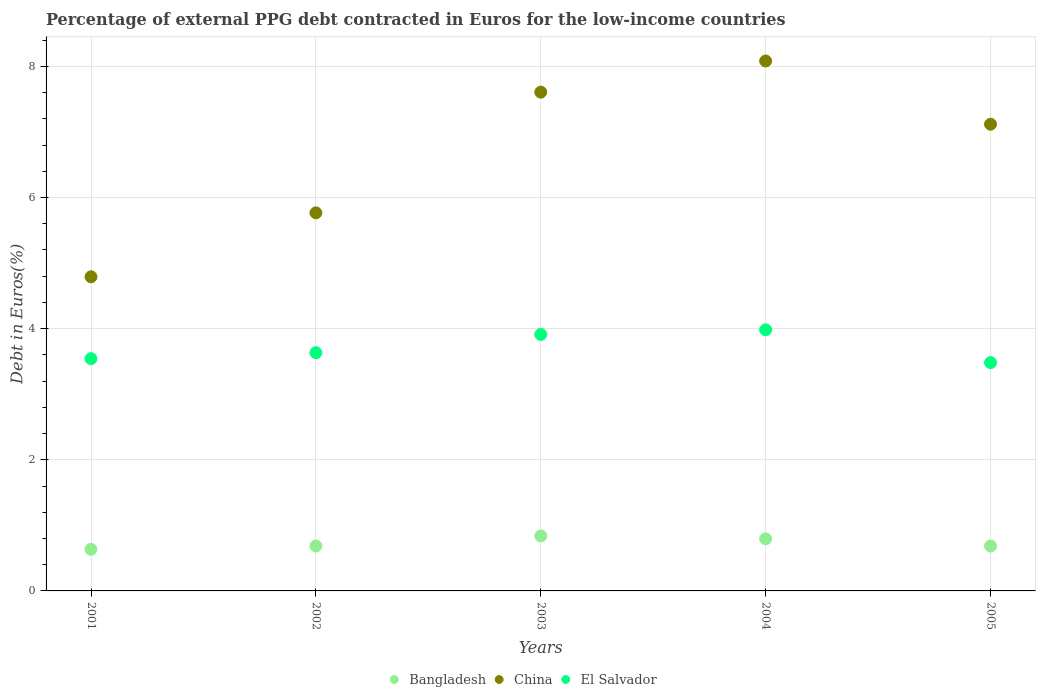How many different coloured dotlines are there?
Your response must be concise. 3. What is the percentage of external PPG debt contracted in Euros in Bangladesh in 2003?
Ensure brevity in your answer.  0.84. Across all years, what is the maximum percentage of external PPG debt contracted in Euros in El Salvador?
Your answer should be very brief. 3.98. Across all years, what is the minimum percentage of external PPG debt contracted in Euros in Bangladesh?
Your answer should be very brief. 0.63. In which year was the percentage of external PPG debt contracted in Euros in El Salvador maximum?
Your answer should be compact. 2004. What is the total percentage of external PPG debt contracted in Euros in El Salvador in the graph?
Your response must be concise. 18.55. What is the difference between the percentage of external PPG debt contracted in Euros in El Salvador in 2003 and that in 2005?
Give a very brief answer. 0.43. What is the difference between the percentage of external PPG debt contracted in Euros in China in 2002 and the percentage of external PPG debt contracted in Euros in El Salvador in 2005?
Your response must be concise. 2.28. What is the average percentage of external PPG debt contracted in Euros in China per year?
Provide a succinct answer. 6.67. In the year 2003, what is the difference between the percentage of external PPG debt contracted in Euros in Bangladesh and percentage of external PPG debt contracted in Euros in El Salvador?
Your response must be concise. -3.07. What is the ratio of the percentage of external PPG debt contracted in Euros in El Salvador in 2001 to that in 2003?
Provide a succinct answer. 0.91. Is the difference between the percentage of external PPG debt contracted in Euros in Bangladesh in 2001 and 2002 greater than the difference between the percentage of external PPG debt contracted in Euros in El Salvador in 2001 and 2002?
Provide a short and direct response. Yes. What is the difference between the highest and the second highest percentage of external PPG debt contracted in Euros in Bangladesh?
Ensure brevity in your answer.  0.04. What is the difference between the highest and the lowest percentage of external PPG debt contracted in Euros in China?
Offer a very short reply. 3.29. In how many years, is the percentage of external PPG debt contracted in Euros in Bangladesh greater than the average percentage of external PPG debt contracted in Euros in Bangladesh taken over all years?
Your answer should be very brief. 2. Is it the case that in every year, the sum of the percentage of external PPG debt contracted in Euros in China and percentage of external PPG debt contracted in Euros in Bangladesh  is greater than the percentage of external PPG debt contracted in Euros in El Salvador?
Make the answer very short. Yes. Is the percentage of external PPG debt contracted in Euros in Bangladesh strictly greater than the percentage of external PPG debt contracted in Euros in China over the years?
Provide a short and direct response. No. How many dotlines are there?
Your response must be concise. 3. How many years are there in the graph?
Give a very brief answer. 5. Are the values on the major ticks of Y-axis written in scientific E-notation?
Offer a very short reply. No. How many legend labels are there?
Ensure brevity in your answer.  3. How are the legend labels stacked?
Your answer should be very brief. Horizontal. What is the title of the graph?
Offer a very short reply. Percentage of external PPG debt contracted in Euros for the low-income countries. What is the label or title of the Y-axis?
Offer a very short reply. Debt in Euros(%). What is the Debt in Euros(%) in Bangladesh in 2001?
Ensure brevity in your answer.  0.63. What is the Debt in Euros(%) in China in 2001?
Your answer should be compact. 4.79. What is the Debt in Euros(%) in El Salvador in 2001?
Your answer should be compact. 3.54. What is the Debt in Euros(%) in Bangladesh in 2002?
Provide a short and direct response. 0.69. What is the Debt in Euros(%) in China in 2002?
Your answer should be compact. 5.77. What is the Debt in Euros(%) in El Salvador in 2002?
Keep it short and to the point. 3.63. What is the Debt in Euros(%) of Bangladesh in 2003?
Give a very brief answer. 0.84. What is the Debt in Euros(%) in China in 2003?
Keep it short and to the point. 7.61. What is the Debt in Euros(%) in El Salvador in 2003?
Keep it short and to the point. 3.91. What is the Debt in Euros(%) in Bangladesh in 2004?
Ensure brevity in your answer.  0.79. What is the Debt in Euros(%) of China in 2004?
Keep it short and to the point. 8.08. What is the Debt in Euros(%) of El Salvador in 2004?
Provide a short and direct response. 3.98. What is the Debt in Euros(%) of Bangladesh in 2005?
Ensure brevity in your answer.  0.68. What is the Debt in Euros(%) of China in 2005?
Provide a short and direct response. 7.12. What is the Debt in Euros(%) in El Salvador in 2005?
Make the answer very short. 3.48. Across all years, what is the maximum Debt in Euros(%) of Bangladesh?
Give a very brief answer. 0.84. Across all years, what is the maximum Debt in Euros(%) of China?
Provide a short and direct response. 8.08. Across all years, what is the maximum Debt in Euros(%) of El Salvador?
Make the answer very short. 3.98. Across all years, what is the minimum Debt in Euros(%) of Bangladesh?
Provide a short and direct response. 0.63. Across all years, what is the minimum Debt in Euros(%) in China?
Offer a very short reply. 4.79. Across all years, what is the minimum Debt in Euros(%) of El Salvador?
Offer a terse response. 3.48. What is the total Debt in Euros(%) of Bangladesh in the graph?
Your response must be concise. 3.64. What is the total Debt in Euros(%) of China in the graph?
Offer a terse response. 33.36. What is the total Debt in Euros(%) in El Salvador in the graph?
Give a very brief answer. 18.55. What is the difference between the Debt in Euros(%) of Bangladesh in 2001 and that in 2002?
Your response must be concise. -0.05. What is the difference between the Debt in Euros(%) in China in 2001 and that in 2002?
Make the answer very short. -0.98. What is the difference between the Debt in Euros(%) of El Salvador in 2001 and that in 2002?
Provide a succinct answer. -0.09. What is the difference between the Debt in Euros(%) of Bangladesh in 2001 and that in 2003?
Provide a succinct answer. -0.2. What is the difference between the Debt in Euros(%) of China in 2001 and that in 2003?
Offer a terse response. -2.82. What is the difference between the Debt in Euros(%) of El Salvador in 2001 and that in 2003?
Offer a very short reply. -0.37. What is the difference between the Debt in Euros(%) of Bangladesh in 2001 and that in 2004?
Provide a succinct answer. -0.16. What is the difference between the Debt in Euros(%) of China in 2001 and that in 2004?
Provide a succinct answer. -3.29. What is the difference between the Debt in Euros(%) in El Salvador in 2001 and that in 2004?
Keep it short and to the point. -0.44. What is the difference between the Debt in Euros(%) in Bangladesh in 2001 and that in 2005?
Keep it short and to the point. -0.05. What is the difference between the Debt in Euros(%) of China in 2001 and that in 2005?
Your answer should be very brief. -2.33. What is the difference between the Debt in Euros(%) of El Salvador in 2001 and that in 2005?
Provide a succinct answer. 0.06. What is the difference between the Debt in Euros(%) of Bangladesh in 2002 and that in 2003?
Your answer should be compact. -0.15. What is the difference between the Debt in Euros(%) in China in 2002 and that in 2003?
Your response must be concise. -1.84. What is the difference between the Debt in Euros(%) of El Salvador in 2002 and that in 2003?
Make the answer very short. -0.28. What is the difference between the Debt in Euros(%) of Bangladesh in 2002 and that in 2004?
Provide a succinct answer. -0.11. What is the difference between the Debt in Euros(%) of China in 2002 and that in 2004?
Ensure brevity in your answer.  -2.32. What is the difference between the Debt in Euros(%) of El Salvador in 2002 and that in 2004?
Make the answer very short. -0.35. What is the difference between the Debt in Euros(%) in Bangladesh in 2002 and that in 2005?
Keep it short and to the point. 0. What is the difference between the Debt in Euros(%) of China in 2002 and that in 2005?
Your answer should be very brief. -1.35. What is the difference between the Debt in Euros(%) in El Salvador in 2002 and that in 2005?
Provide a short and direct response. 0.15. What is the difference between the Debt in Euros(%) in Bangladesh in 2003 and that in 2004?
Your response must be concise. 0.04. What is the difference between the Debt in Euros(%) of China in 2003 and that in 2004?
Offer a terse response. -0.48. What is the difference between the Debt in Euros(%) of El Salvador in 2003 and that in 2004?
Provide a short and direct response. -0.07. What is the difference between the Debt in Euros(%) in Bangladesh in 2003 and that in 2005?
Keep it short and to the point. 0.15. What is the difference between the Debt in Euros(%) of China in 2003 and that in 2005?
Provide a succinct answer. 0.49. What is the difference between the Debt in Euros(%) in El Salvador in 2003 and that in 2005?
Provide a succinct answer. 0.43. What is the difference between the Debt in Euros(%) of Bangladesh in 2004 and that in 2005?
Your response must be concise. 0.11. What is the difference between the Debt in Euros(%) in El Salvador in 2004 and that in 2005?
Your answer should be compact. 0.5. What is the difference between the Debt in Euros(%) in Bangladesh in 2001 and the Debt in Euros(%) in China in 2002?
Your answer should be very brief. -5.13. What is the difference between the Debt in Euros(%) of Bangladesh in 2001 and the Debt in Euros(%) of El Salvador in 2002?
Provide a succinct answer. -3. What is the difference between the Debt in Euros(%) in China in 2001 and the Debt in Euros(%) in El Salvador in 2002?
Ensure brevity in your answer.  1.16. What is the difference between the Debt in Euros(%) in Bangladesh in 2001 and the Debt in Euros(%) in China in 2003?
Ensure brevity in your answer.  -6.97. What is the difference between the Debt in Euros(%) of Bangladesh in 2001 and the Debt in Euros(%) of El Salvador in 2003?
Your response must be concise. -3.28. What is the difference between the Debt in Euros(%) of China in 2001 and the Debt in Euros(%) of El Salvador in 2003?
Provide a succinct answer. 0.88. What is the difference between the Debt in Euros(%) of Bangladesh in 2001 and the Debt in Euros(%) of China in 2004?
Keep it short and to the point. -7.45. What is the difference between the Debt in Euros(%) in Bangladesh in 2001 and the Debt in Euros(%) in El Salvador in 2004?
Make the answer very short. -3.35. What is the difference between the Debt in Euros(%) in China in 2001 and the Debt in Euros(%) in El Salvador in 2004?
Provide a succinct answer. 0.81. What is the difference between the Debt in Euros(%) in Bangladesh in 2001 and the Debt in Euros(%) in China in 2005?
Provide a succinct answer. -6.48. What is the difference between the Debt in Euros(%) in Bangladesh in 2001 and the Debt in Euros(%) in El Salvador in 2005?
Provide a short and direct response. -2.85. What is the difference between the Debt in Euros(%) in China in 2001 and the Debt in Euros(%) in El Salvador in 2005?
Your response must be concise. 1.31. What is the difference between the Debt in Euros(%) in Bangladesh in 2002 and the Debt in Euros(%) in China in 2003?
Offer a very short reply. -6.92. What is the difference between the Debt in Euros(%) of Bangladesh in 2002 and the Debt in Euros(%) of El Salvador in 2003?
Your answer should be compact. -3.23. What is the difference between the Debt in Euros(%) of China in 2002 and the Debt in Euros(%) of El Salvador in 2003?
Provide a succinct answer. 1.85. What is the difference between the Debt in Euros(%) of Bangladesh in 2002 and the Debt in Euros(%) of China in 2004?
Your response must be concise. -7.4. What is the difference between the Debt in Euros(%) of Bangladesh in 2002 and the Debt in Euros(%) of El Salvador in 2004?
Keep it short and to the point. -3.3. What is the difference between the Debt in Euros(%) of China in 2002 and the Debt in Euros(%) of El Salvador in 2004?
Your response must be concise. 1.78. What is the difference between the Debt in Euros(%) in Bangladesh in 2002 and the Debt in Euros(%) in China in 2005?
Your answer should be very brief. -6.43. What is the difference between the Debt in Euros(%) of Bangladesh in 2002 and the Debt in Euros(%) of El Salvador in 2005?
Provide a succinct answer. -2.8. What is the difference between the Debt in Euros(%) of China in 2002 and the Debt in Euros(%) of El Salvador in 2005?
Provide a short and direct response. 2.28. What is the difference between the Debt in Euros(%) in Bangladesh in 2003 and the Debt in Euros(%) in China in 2004?
Ensure brevity in your answer.  -7.24. What is the difference between the Debt in Euros(%) in Bangladesh in 2003 and the Debt in Euros(%) in El Salvador in 2004?
Give a very brief answer. -3.14. What is the difference between the Debt in Euros(%) of China in 2003 and the Debt in Euros(%) of El Salvador in 2004?
Keep it short and to the point. 3.62. What is the difference between the Debt in Euros(%) in Bangladesh in 2003 and the Debt in Euros(%) in China in 2005?
Ensure brevity in your answer.  -6.28. What is the difference between the Debt in Euros(%) of Bangladesh in 2003 and the Debt in Euros(%) of El Salvador in 2005?
Your answer should be compact. -2.64. What is the difference between the Debt in Euros(%) of China in 2003 and the Debt in Euros(%) of El Salvador in 2005?
Offer a very short reply. 4.13. What is the difference between the Debt in Euros(%) of Bangladesh in 2004 and the Debt in Euros(%) of China in 2005?
Keep it short and to the point. -6.32. What is the difference between the Debt in Euros(%) of Bangladesh in 2004 and the Debt in Euros(%) of El Salvador in 2005?
Ensure brevity in your answer.  -2.69. What is the difference between the Debt in Euros(%) in China in 2004 and the Debt in Euros(%) in El Salvador in 2005?
Give a very brief answer. 4.6. What is the average Debt in Euros(%) of Bangladesh per year?
Ensure brevity in your answer.  0.73. What is the average Debt in Euros(%) in China per year?
Provide a short and direct response. 6.67. What is the average Debt in Euros(%) of El Salvador per year?
Ensure brevity in your answer.  3.71. In the year 2001, what is the difference between the Debt in Euros(%) of Bangladesh and Debt in Euros(%) of China?
Offer a very short reply. -4.16. In the year 2001, what is the difference between the Debt in Euros(%) of Bangladesh and Debt in Euros(%) of El Salvador?
Your answer should be very brief. -2.91. In the year 2001, what is the difference between the Debt in Euros(%) in China and Debt in Euros(%) in El Salvador?
Keep it short and to the point. 1.25. In the year 2002, what is the difference between the Debt in Euros(%) in Bangladesh and Debt in Euros(%) in China?
Keep it short and to the point. -5.08. In the year 2002, what is the difference between the Debt in Euros(%) in Bangladesh and Debt in Euros(%) in El Salvador?
Provide a succinct answer. -2.95. In the year 2002, what is the difference between the Debt in Euros(%) in China and Debt in Euros(%) in El Salvador?
Offer a terse response. 2.13. In the year 2003, what is the difference between the Debt in Euros(%) in Bangladesh and Debt in Euros(%) in China?
Keep it short and to the point. -6.77. In the year 2003, what is the difference between the Debt in Euros(%) in Bangladesh and Debt in Euros(%) in El Salvador?
Ensure brevity in your answer.  -3.07. In the year 2003, what is the difference between the Debt in Euros(%) in China and Debt in Euros(%) in El Salvador?
Make the answer very short. 3.69. In the year 2004, what is the difference between the Debt in Euros(%) in Bangladesh and Debt in Euros(%) in China?
Offer a terse response. -7.29. In the year 2004, what is the difference between the Debt in Euros(%) in Bangladesh and Debt in Euros(%) in El Salvador?
Offer a very short reply. -3.19. In the year 2004, what is the difference between the Debt in Euros(%) of China and Debt in Euros(%) of El Salvador?
Offer a very short reply. 4.1. In the year 2005, what is the difference between the Debt in Euros(%) of Bangladesh and Debt in Euros(%) of China?
Keep it short and to the point. -6.43. In the year 2005, what is the difference between the Debt in Euros(%) in Bangladesh and Debt in Euros(%) in El Salvador?
Offer a terse response. -2.8. In the year 2005, what is the difference between the Debt in Euros(%) in China and Debt in Euros(%) in El Salvador?
Make the answer very short. 3.64. What is the ratio of the Debt in Euros(%) in Bangladesh in 2001 to that in 2002?
Make the answer very short. 0.93. What is the ratio of the Debt in Euros(%) of China in 2001 to that in 2002?
Your response must be concise. 0.83. What is the ratio of the Debt in Euros(%) in El Salvador in 2001 to that in 2002?
Make the answer very short. 0.97. What is the ratio of the Debt in Euros(%) in Bangladesh in 2001 to that in 2003?
Keep it short and to the point. 0.76. What is the ratio of the Debt in Euros(%) in China in 2001 to that in 2003?
Offer a very short reply. 0.63. What is the ratio of the Debt in Euros(%) in El Salvador in 2001 to that in 2003?
Your answer should be compact. 0.91. What is the ratio of the Debt in Euros(%) of Bangladesh in 2001 to that in 2004?
Ensure brevity in your answer.  0.8. What is the ratio of the Debt in Euros(%) of China in 2001 to that in 2004?
Your answer should be compact. 0.59. What is the ratio of the Debt in Euros(%) of El Salvador in 2001 to that in 2004?
Ensure brevity in your answer.  0.89. What is the ratio of the Debt in Euros(%) of Bangladesh in 2001 to that in 2005?
Give a very brief answer. 0.93. What is the ratio of the Debt in Euros(%) in China in 2001 to that in 2005?
Provide a short and direct response. 0.67. What is the ratio of the Debt in Euros(%) in El Salvador in 2001 to that in 2005?
Your response must be concise. 1.02. What is the ratio of the Debt in Euros(%) of Bangladesh in 2002 to that in 2003?
Keep it short and to the point. 0.82. What is the ratio of the Debt in Euros(%) in China in 2002 to that in 2003?
Give a very brief answer. 0.76. What is the ratio of the Debt in Euros(%) of El Salvador in 2002 to that in 2003?
Your response must be concise. 0.93. What is the ratio of the Debt in Euros(%) of Bangladesh in 2002 to that in 2004?
Provide a succinct answer. 0.86. What is the ratio of the Debt in Euros(%) of China in 2002 to that in 2004?
Your answer should be very brief. 0.71. What is the ratio of the Debt in Euros(%) in El Salvador in 2002 to that in 2004?
Offer a terse response. 0.91. What is the ratio of the Debt in Euros(%) in China in 2002 to that in 2005?
Make the answer very short. 0.81. What is the ratio of the Debt in Euros(%) in El Salvador in 2002 to that in 2005?
Make the answer very short. 1.04. What is the ratio of the Debt in Euros(%) in Bangladesh in 2003 to that in 2004?
Keep it short and to the point. 1.06. What is the ratio of the Debt in Euros(%) of China in 2003 to that in 2004?
Offer a very short reply. 0.94. What is the ratio of the Debt in Euros(%) of El Salvador in 2003 to that in 2004?
Your answer should be very brief. 0.98. What is the ratio of the Debt in Euros(%) of Bangladesh in 2003 to that in 2005?
Offer a very short reply. 1.23. What is the ratio of the Debt in Euros(%) in China in 2003 to that in 2005?
Your answer should be compact. 1.07. What is the ratio of the Debt in Euros(%) of El Salvador in 2003 to that in 2005?
Provide a succinct answer. 1.12. What is the ratio of the Debt in Euros(%) of Bangladesh in 2004 to that in 2005?
Provide a short and direct response. 1.16. What is the ratio of the Debt in Euros(%) of China in 2004 to that in 2005?
Your answer should be very brief. 1.14. What is the ratio of the Debt in Euros(%) of El Salvador in 2004 to that in 2005?
Your response must be concise. 1.14. What is the difference between the highest and the second highest Debt in Euros(%) of Bangladesh?
Your answer should be compact. 0.04. What is the difference between the highest and the second highest Debt in Euros(%) of China?
Provide a succinct answer. 0.48. What is the difference between the highest and the second highest Debt in Euros(%) in El Salvador?
Your answer should be compact. 0.07. What is the difference between the highest and the lowest Debt in Euros(%) in Bangladesh?
Your answer should be very brief. 0.2. What is the difference between the highest and the lowest Debt in Euros(%) in China?
Your answer should be very brief. 3.29. What is the difference between the highest and the lowest Debt in Euros(%) of El Salvador?
Offer a terse response. 0.5. 